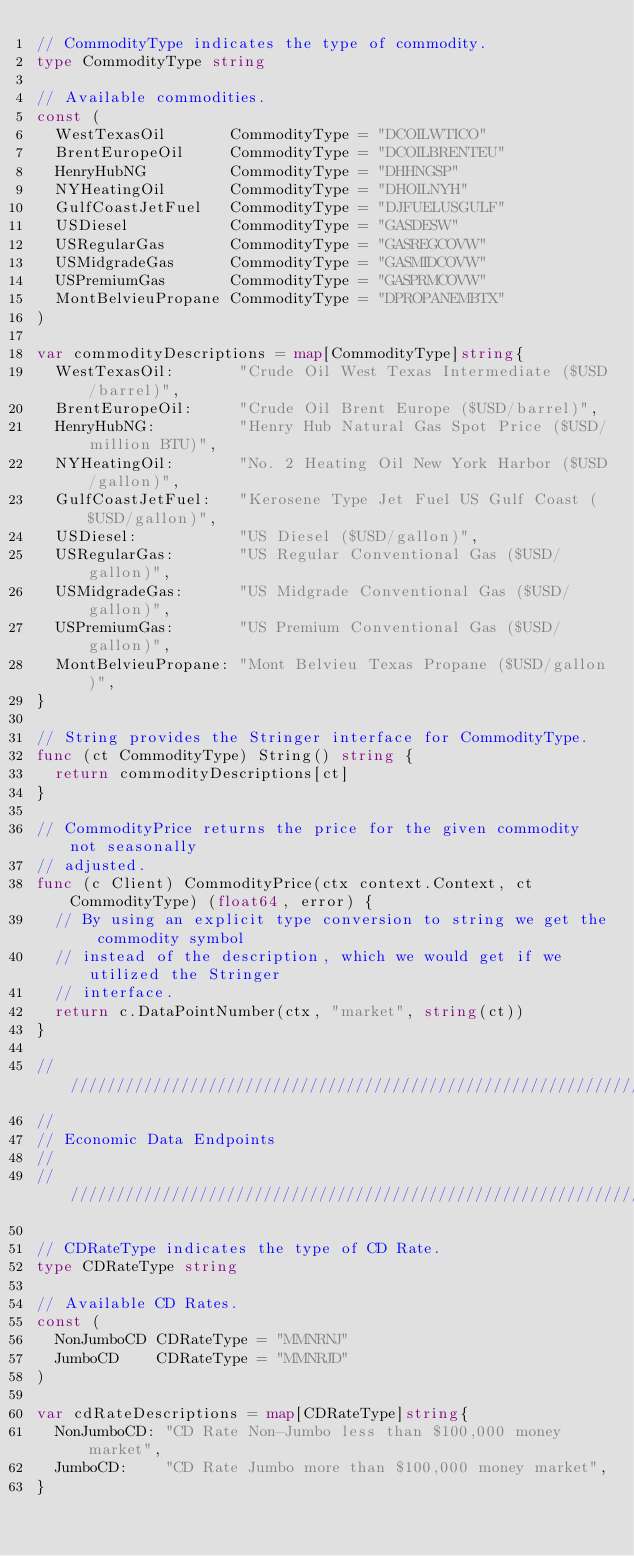Convert code to text. <code><loc_0><loc_0><loc_500><loc_500><_Go_>// CommodityType indicates the type of commodity.
type CommodityType string

// Available commodities.
const (
	WestTexasOil       CommodityType = "DCOILWTICO"
	BrentEuropeOil     CommodityType = "DCOILBRENTEU"
	HenryHubNG         CommodityType = "DHHNGSP"
	NYHeatingOil       CommodityType = "DHOILNYH"
	GulfCoastJetFuel   CommodityType = "DJFUELUSGULF"
	USDiesel           CommodityType = "GASDESW"
	USRegularGas       CommodityType = "GASREGCOVW"
	USMidgradeGas      CommodityType = "GASMIDCOVW"
	USPremiumGas       CommodityType = "GASPRMCOVW"
	MontBelvieuPropane CommodityType = "DPROPANEMBTX"
)

var commodityDescriptions = map[CommodityType]string{
	WestTexasOil:       "Crude Oil West Texas Intermediate ($USD/barrel)",
	BrentEuropeOil:     "Crude Oil Brent Europe ($USD/barrel)",
	HenryHubNG:         "Henry Hub Natural Gas Spot Price ($USD/million BTU)",
	NYHeatingOil:       "No. 2 Heating Oil New York Harbor ($USD/gallon)",
	GulfCoastJetFuel:   "Kerosene Type Jet Fuel US Gulf Coast ($USD/gallon)",
	USDiesel:           "US Diesel ($USD/gallon)",
	USRegularGas:       "US Regular Conventional Gas ($USD/gallon)",
	USMidgradeGas:      "US Midgrade Conventional Gas ($USD/gallon)",
	USPremiumGas:       "US Premium Conventional Gas ($USD/gallon)",
	MontBelvieuPropane: "Mont Belvieu Texas Propane ($USD/gallon)",
}

// String provides the Stringer interface for CommodityType.
func (ct CommodityType) String() string {
	return commodityDescriptions[ct]
}

// CommodityPrice returns the price for the given commodity not seasonally
// adjusted.
func (c Client) CommodityPrice(ctx context.Context, ct CommodityType) (float64, error) {
	// By using an explicit type conversion to string we get the commodity symbol
	// instead of the description, which we would get if we utilized the Stringer
	// interface.
	return c.DataPointNumber(ctx, "market", string(ct))
}

//////////////////////////////////////////////////////////////////////////////
//
// Economic Data Endpoints
//
//////////////////////////////////////////////////////////////////////////////

// CDRateType indicates the type of CD Rate.
type CDRateType string

// Available CD Rates.
const (
	NonJumboCD CDRateType = "MMNRNJ"
	JumboCD    CDRateType = "MMNRJD"
)

var cdRateDescriptions = map[CDRateType]string{
	NonJumboCD: "CD Rate Non-Jumbo less than $100,000 money market",
	JumboCD:    "CD Rate Jumbo more than $100,000 money market",
}
</code> 